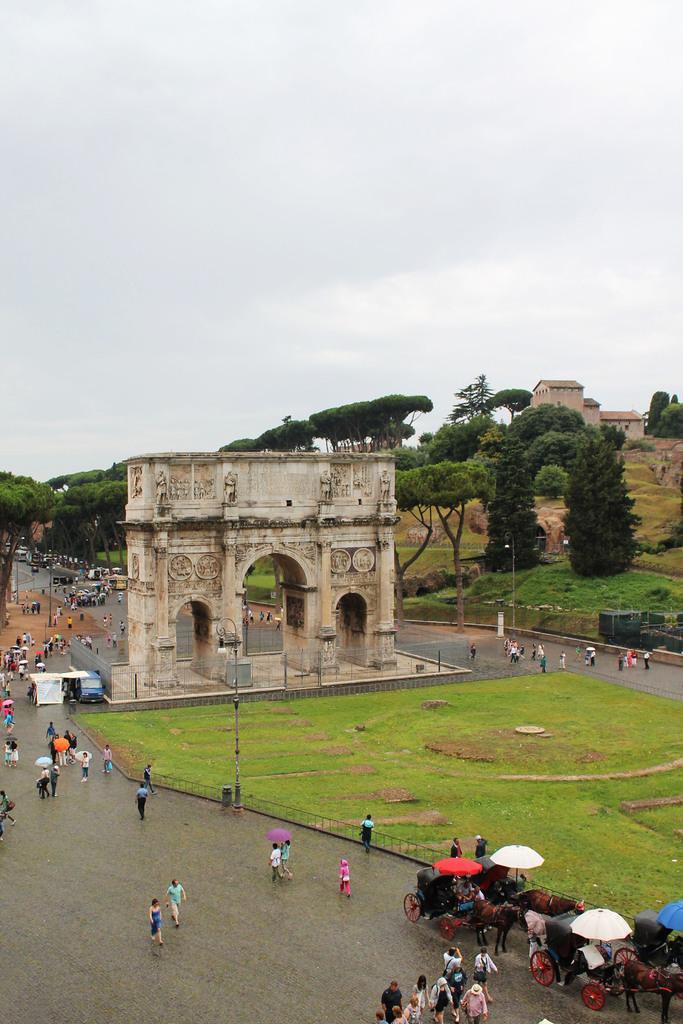In one or two sentences, can you explain what this image depicts? In the image there is a monument and in front of the monument there is a garden. Around that area there are many people moving and there are also few horse carts, in the background there are plenty of trees and on the right side there is a building. 